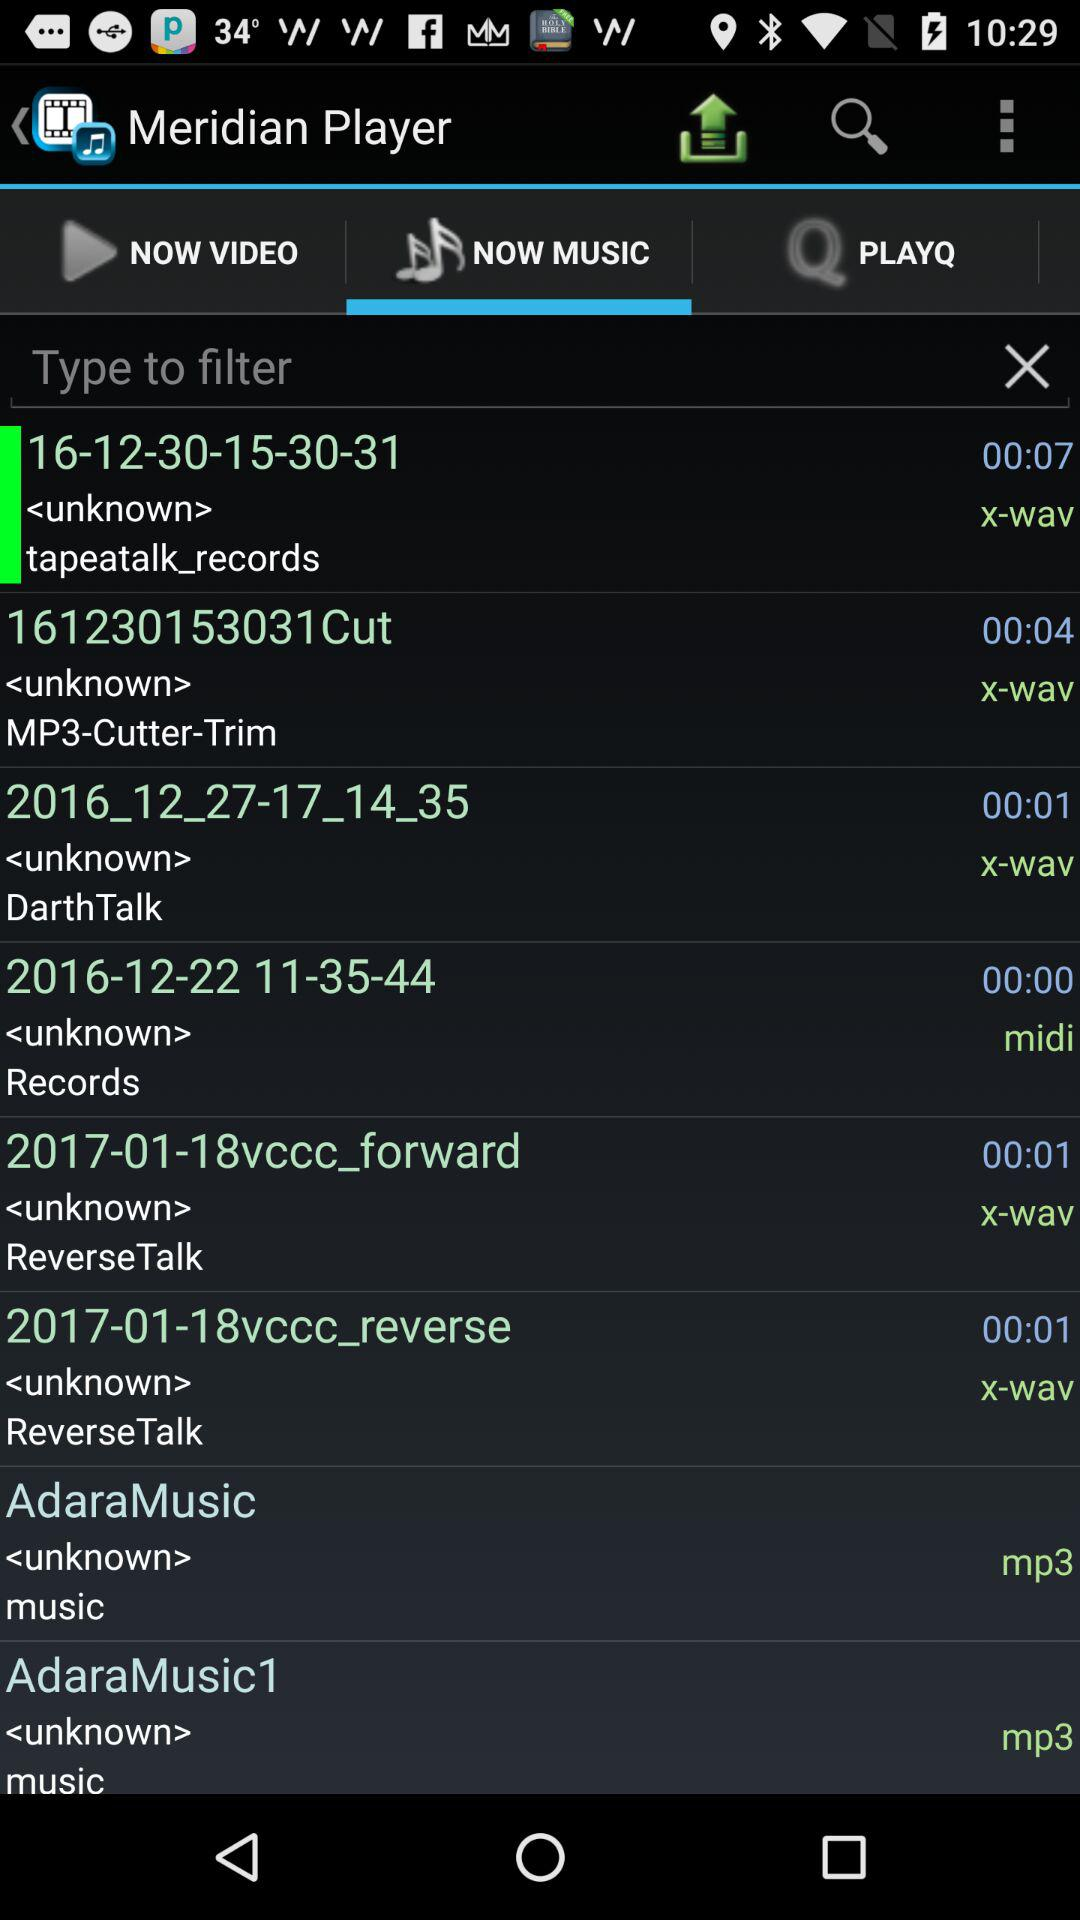What is the duration of "16-12-30-15-30-31"? The duration of "16-12-30-15-30-31" is 7 seconds. 